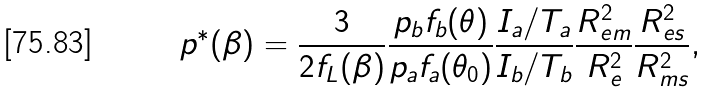<formula> <loc_0><loc_0><loc_500><loc_500>p ^ { * } ( \beta ) = \frac { 3 } { 2 f _ { L } ( \beta ) } \frac { p _ { b } f _ { b } ( \theta ) } { p _ { a } f _ { a } ( \theta _ { 0 } ) } \frac { I _ { a } / T _ { a } } { I _ { b } / T _ { b } } \frac { R ^ { 2 } _ { e m } } { R ^ { 2 } _ { e } } \frac { R ^ { 2 } _ { e s } } { R ^ { 2 } _ { m s } } ,</formula> 